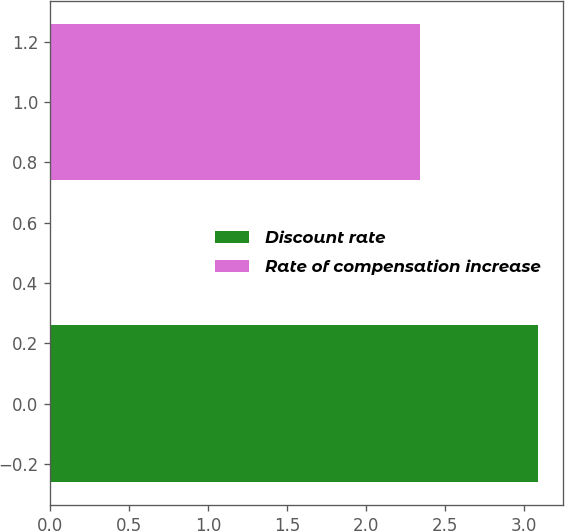Convert chart. <chart><loc_0><loc_0><loc_500><loc_500><bar_chart><fcel>Discount rate<fcel>Rate of compensation increase<nl><fcel>3.09<fcel>2.34<nl></chart> 